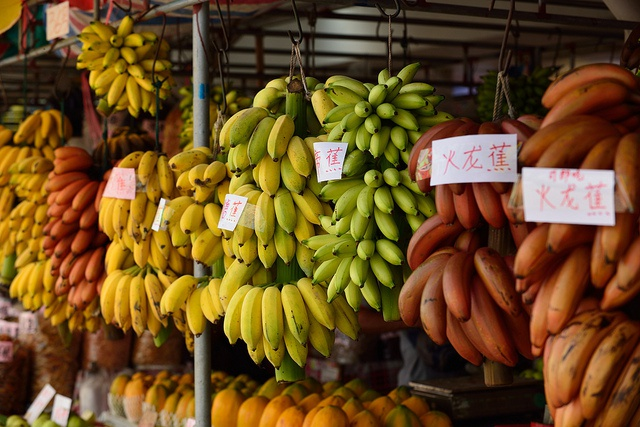Describe the objects in this image and their specific colors. I can see banana in olive, black, and maroon tones, banana in olive, maroon, brown, and black tones, banana in olive and black tones, banana in olive, maroon, black, brown, and lavender tones, and banana in olive and orange tones in this image. 